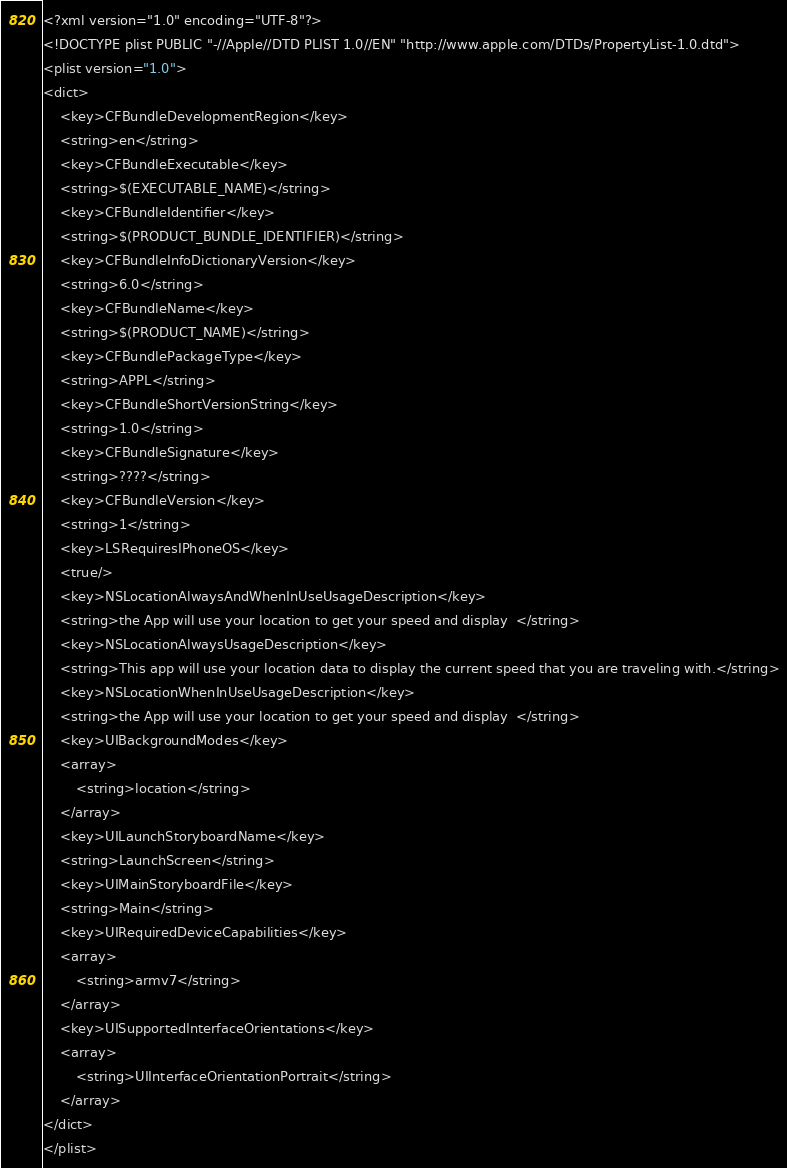<code> <loc_0><loc_0><loc_500><loc_500><_XML_><?xml version="1.0" encoding="UTF-8"?>
<!DOCTYPE plist PUBLIC "-//Apple//DTD PLIST 1.0//EN" "http://www.apple.com/DTDs/PropertyList-1.0.dtd">
<plist version="1.0">
<dict>
	<key>CFBundleDevelopmentRegion</key>
	<string>en</string>
	<key>CFBundleExecutable</key>
	<string>$(EXECUTABLE_NAME)</string>
	<key>CFBundleIdentifier</key>
	<string>$(PRODUCT_BUNDLE_IDENTIFIER)</string>
	<key>CFBundleInfoDictionaryVersion</key>
	<string>6.0</string>
	<key>CFBundleName</key>
	<string>$(PRODUCT_NAME)</string>
	<key>CFBundlePackageType</key>
	<string>APPL</string>
	<key>CFBundleShortVersionString</key>
	<string>1.0</string>
	<key>CFBundleSignature</key>
	<string>????</string>
	<key>CFBundleVersion</key>
	<string>1</string>
	<key>LSRequiresIPhoneOS</key>
	<true/>
	<key>NSLocationAlwaysAndWhenInUseUsageDescription</key>
	<string>the App will use your location to get your speed and display  </string>
	<key>NSLocationAlwaysUsageDescription</key>
	<string>This app will use your location data to display the current speed that you are traveling with.</string>
	<key>NSLocationWhenInUseUsageDescription</key>
	<string>the App will use your location to get your speed and display  </string>
	<key>UIBackgroundModes</key>
	<array>
		<string>location</string>
	</array>
	<key>UILaunchStoryboardName</key>
	<string>LaunchScreen</string>
	<key>UIMainStoryboardFile</key>
	<string>Main</string>
	<key>UIRequiredDeviceCapabilities</key>
	<array>
		<string>armv7</string>
	</array>
	<key>UISupportedInterfaceOrientations</key>
	<array>
		<string>UIInterfaceOrientationPortrait</string>
	</array>
</dict>
</plist>
</code> 